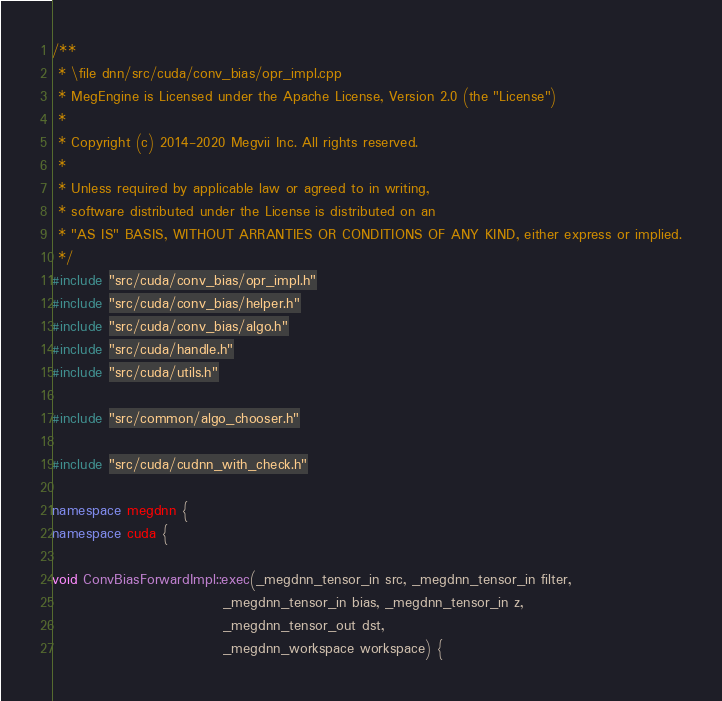<code> <loc_0><loc_0><loc_500><loc_500><_C++_>/**
 * \file dnn/src/cuda/conv_bias/opr_impl.cpp
 * MegEngine is Licensed under the Apache License, Version 2.0 (the "License")
 *
 * Copyright (c) 2014-2020 Megvii Inc. All rights reserved.
 *
 * Unless required by applicable law or agreed to in writing,
 * software distributed under the License is distributed on an
 * "AS IS" BASIS, WITHOUT ARRANTIES OR CONDITIONS OF ANY KIND, either express or implied.
 */
#include "src/cuda/conv_bias/opr_impl.h"
#include "src/cuda/conv_bias/helper.h"
#include "src/cuda/conv_bias/algo.h"
#include "src/cuda/handle.h"
#include "src/cuda/utils.h"

#include "src/common/algo_chooser.h"

#include "src/cuda/cudnn_with_check.h"

namespace megdnn {
namespace cuda {

void ConvBiasForwardImpl::exec(_megdnn_tensor_in src, _megdnn_tensor_in filter,
                               _megdnn_tensor_in bias, _megdnn_tensor_in z,
                               _megdnn_tensor_out dst,
                               _megdnn_workspace workspace) {</code> 